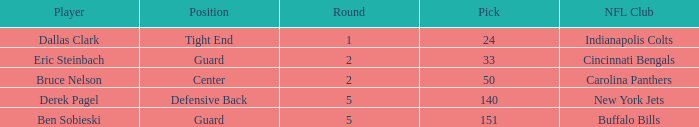What was the last round where derek pagel was drafted with a pick exceeding 50? 5.0. Parse the full table. {'header': ['Player', 'Position', 'Round', 'Pick', 'NFL Club'], 'rows': [['Dallas Clark', 'Tight End', '1', '24', 'Indianapolis Colts'], ['Eric Steinbach', 'Guard', '2', '33', 'Cincinnati Bengals'], ['Bruce Nelson', 'Center', '2', '50', 'Carolina Panthers'], ['Derek Pagel', 'Defensive Back', '5', '140', 'New York Jets'], ['Ben Sobieski', 'Guard', '5', '151', 'Buffalo Bills']]} 